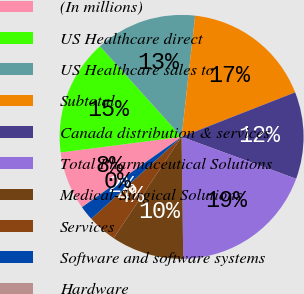Convert chart to OTSL. <chart><loc_0><loc_0><loc_500><loc_500><pie_chart><fcel>(In millions)<fcel>US Healthcare direct<fcel>US Healthcare sales to<fcel>Subtotal<fcel>Canada distribution & services<fcel>Total Pharmaceutical Solutions<fcel>Medical-Surgical Solutions<fcel>Services<fcel>Software and software systems<fcel>Hardware<nl><fcel>7.7%<fcel>15.37%<fcel>13.45%<fcel>17.28%<fcel>11.53%<fcel>19.2%<fcel>9.62%<fcel>3.87%<fcel>1.95%<fcel>0.03%<nl></chart> 